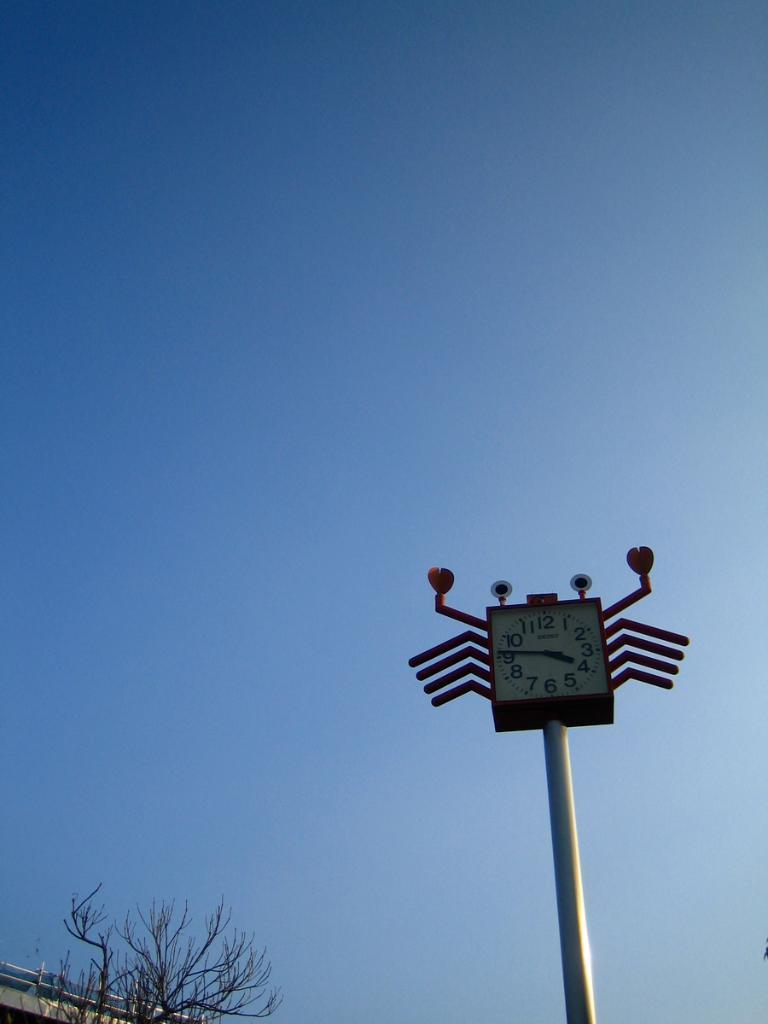In one or two sentences, can you explain what this image depicts? In this picture at the top we see the sky is blue. At the the bottom we can see a pole with a clock. 